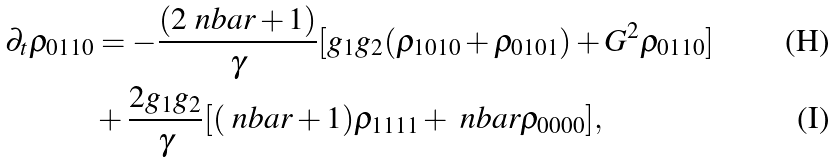<formula> <loc_0><loc_0><loc_500><loc_500>\partial _ { t } { \varrho _ { 0 1 1 0 } } & = - \frac { ( 2 \ n b a r + 1 ) } { \gamma } [ g _ { 1 } g _ { 2 } ( \rho _ { 1 0 1 0 } + \rho _ { 0 1 0 1 } ) + G ^ { 2 } \rho _ { 0 1 1 0 } ] \\ & + \frac { 2 g _ { 1 } g _ { 2 } } { \gamma } [ ( \ n b a r + 1 ) \rho _ { 1 1 1 1 } + \ n b a r \rho _ { 0 0 0 0 } ] ,</formula> 